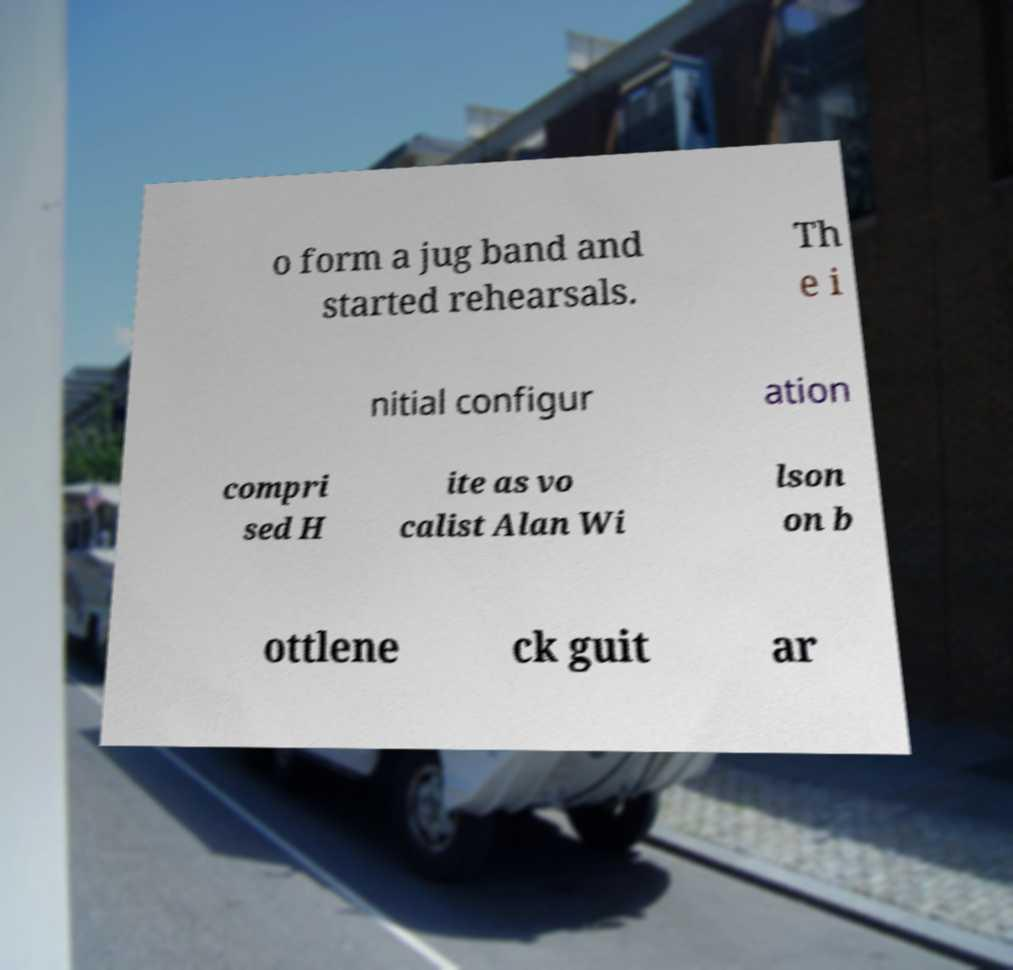For documentation purposes, I need the text within this image transcribed. Could you provide that? o form a jug band and started rehearsals. Th e i nitial configur ation compri sed H ite as vo calist Alan Wi lson on b ottlene ck guit ar 